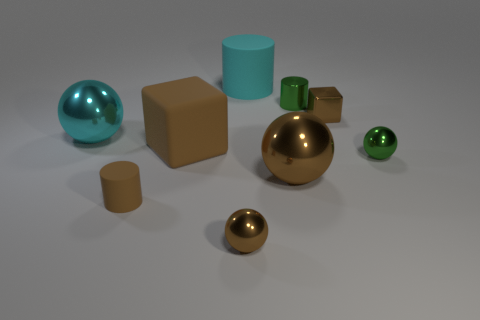There is a thing that is to the left of the brown matte block and to the right of the big cyan metallic object; what material is it made of?
Offer a very short reply. Rubber. There is a small cylinder that is in front of the tiny green ball; what color is it?
Provide a succinct answer. Brown. Is the number of green cylinders on the right side of the green shiny ball greater than the number of tiny red cylinders?
Offer a terse response. No. What number of other objects are there of the same size as the metallic cylinder?
Give a very brief answer. 4. How many green things are on the right side of the tiny shiny block?
Provide a succinct answer. 1. Are there an equal number of cyan metallic spheres that are behind the large cyan matte thing and small spheres that are behind the large cyan metal object?
Your answer should be compact. Yes. There is a green thing that is the same shape as the cyan rubber thing; what size is it?
Give a very brief answer. Small. The tiny thing that is to the left of the brown rubber block has what shape?
Offer a very short reply. Cylinder. Are the small cylinder that is left of the small green metallic cylinder and the big brown thing that is in front of the green metallic sphere made of the same material?
Your answer should be compact. No. What shape is the large cyan rubber object?
Your response must be concise. Cylinder. 